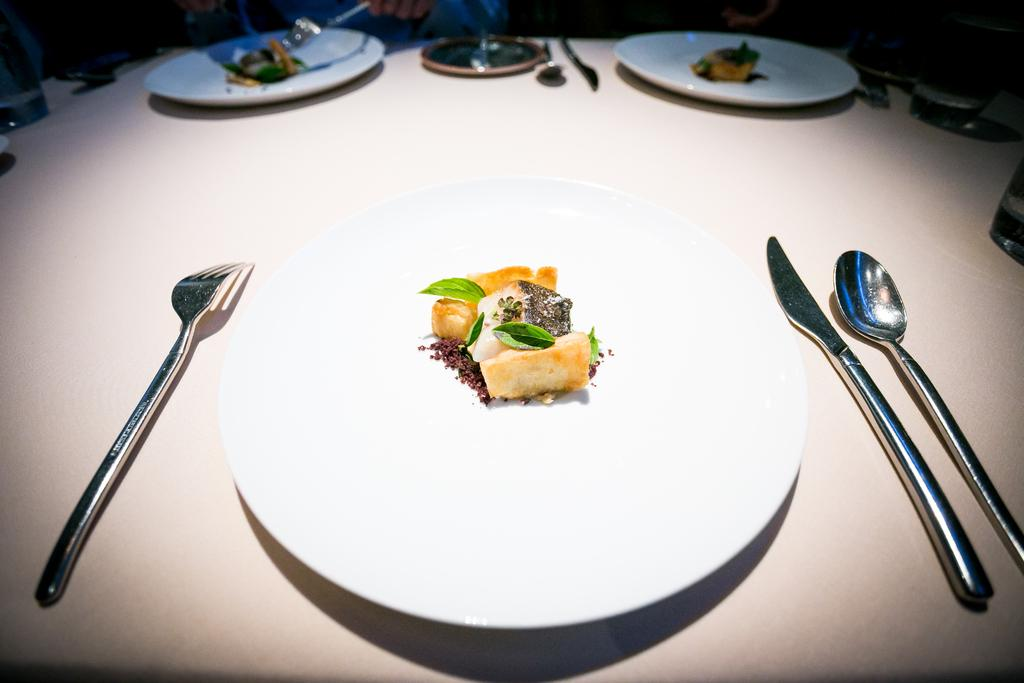What is on the plate that is visible in the image? There is a plate with dessert in the image. What type of garnish is on the dessert? Mint leaves are present on the plate. What utensils are visible in the image? There are forks, spoons, and a knife in the image. Where are the plate, mint leaves, forks, spoons, and knife located? They are on a table. What type of cream is being used to form the table in the image? There is no cream being used to form the table in the image; it is a solid surface. 